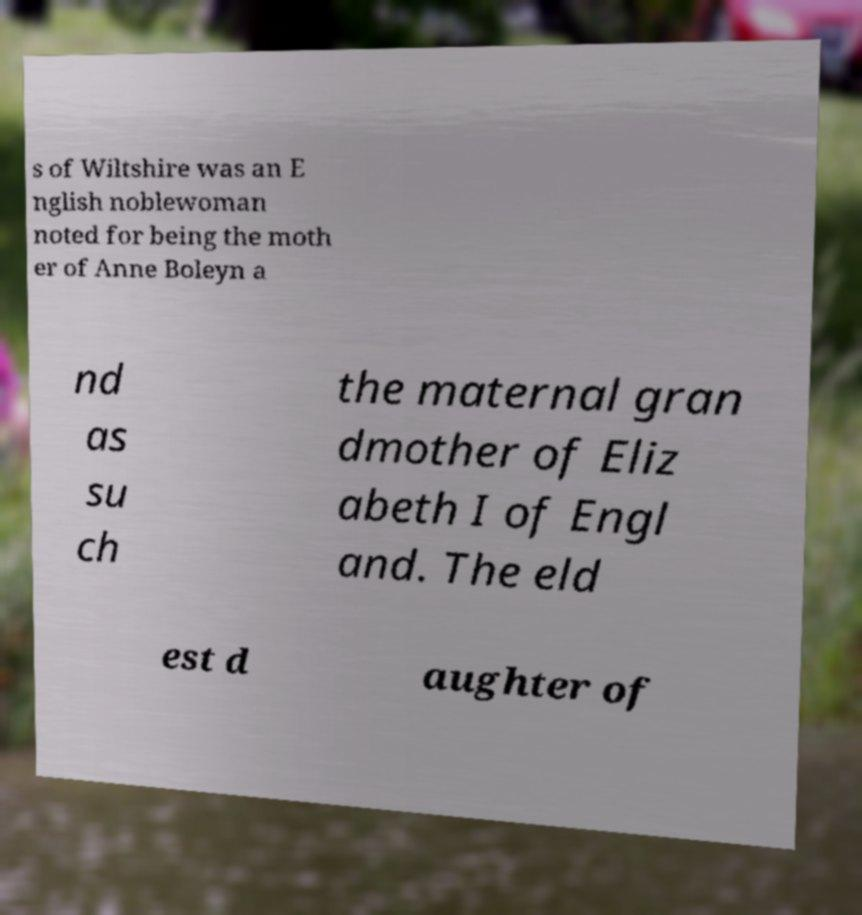Can you read and provide the text displayed in the image?This photo seems to have some interesting text. Can you extract and type it out for me? s of Wiltshire was an E nglish noblewoman noted for being the moth er of Anne Boleyn a nd as su ch the maternal gran dmother of Eliz abeth I of Engl and. The eld est d aughter of 